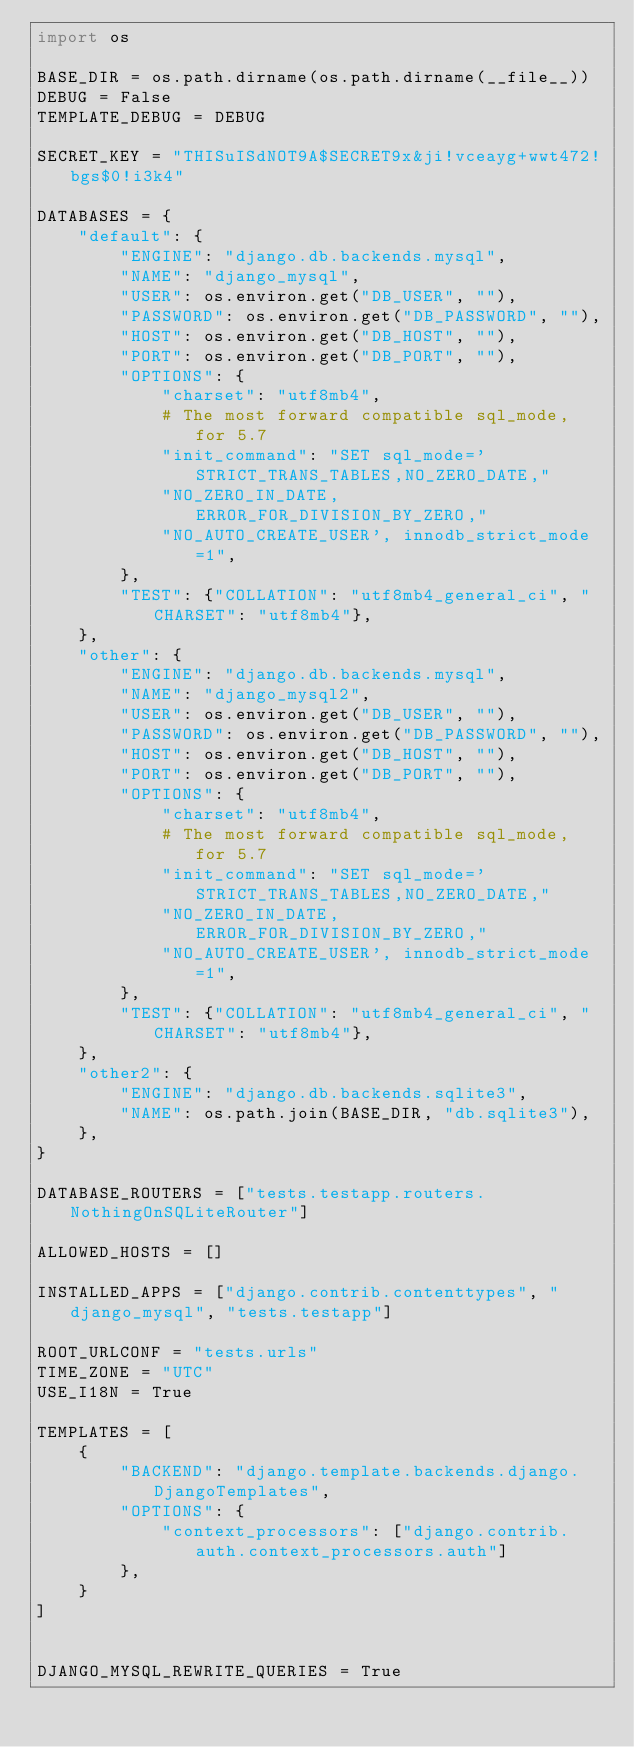Convert code to text. <code><loc_0><loc_0><loc_500><loc_500><_Python_>import os

BASE_DIR = os.path.dirname(os.path.dirname(__file__))
DEBUG = False
TEMPLATE_DEBUG = DEBUG

SECRET_KEY = "THISuISdNOT9A$SECRET9x&ji!vceayg+wwt472!bgs$0!i3k4"

DATABASES = {
    "default": {
        "ENGINE": "django.db.backends.mysql",
        "NAME": "django_mysql",
        "USER": os.environ.get("DB_USER", ""),
        "PASSWORD": os.environ.get("DB_PASSWORD", ""),
        "HOST": os.environ.get("DB_HOST", ""),
        "PORT": os.environ.get("DB_PORT", ""),
        "OPTIONS": {
            "charset": "utf8mb4",
            # The most forward compatible sql_mode, for 5.7
            "init_command": "SET sql_mode='STRICT_TRANS_TABLES,NO_ZERO_DATE,"
            "NO_ZERO_IN_DATE,ERROR_FOR_DIVISION_BY_ZERO,"
            "NO_AUTO_CREATE_USER', innodb_strict_mode=1",
        },
        "TEST": {"COLLATION": "utf8mb4_general_ci", "CHARSET": "utf8mb4"},
    },
    "other": {
        "ENGINE": "django.db.backends.mysql",
        "NAME": "django_mysql2",
        "USER": os.environ.get("DB_USER", ""),
        "PASSWORD": os.environ.get("DB_PASSWORD", ""),
        "HOST": os.environ.get("DB_HOST", ""),
        "PORT": os.environ.get("DB_PORT", ""),
        "OPTIONS": {
            "charset": "utf8mb4",
            # The most forward compatible sql_mode, for 5.7
            "init_command": "SET sql_mode='STRICT_TRANS_TABLES,NO_ZERO_DATE,"
            "NO_ZERO_IN_DATE,ERROR_FOR_DIVISION_BY_ZERO,"
            "NO_AUTO_CREATE_USER', innodb_strict_mode=1",
        },
        "TEST": {"COLLATION": "utf8mb4_general_ci", "CHARSET": "utf8mb4"},
    },
    "other2": {
        "ENGINE": "django.db.backends.sqlite3",
        "NAME": os.path.join(BASE_DIR, "db.sqlite3"),
    },
}

DATABASE_ROUTERS = ["tests.testapp.routers.NothingOnSQLiteRouter"]

ALLOWED_HOSTS = []

INSTALLED_APPS = ["django.contrib.contenttypes", "django_mysql", "tests.testapp"]

ROOT_URLCONF = "tests.urls"
TIME_ZONE = "UTC"
USE_I18N = True

TEMPLATES = [
    {
        "BACKEND": "django.template.backends.django.DjangoTemplates",
        "OPTIONS": {
            "context_processors": ["django.contrib.auth.context_processors.auth"]
        },
    }
]


DJANGO_MYSQL_REWRITE_QUERIES = True
</code> 